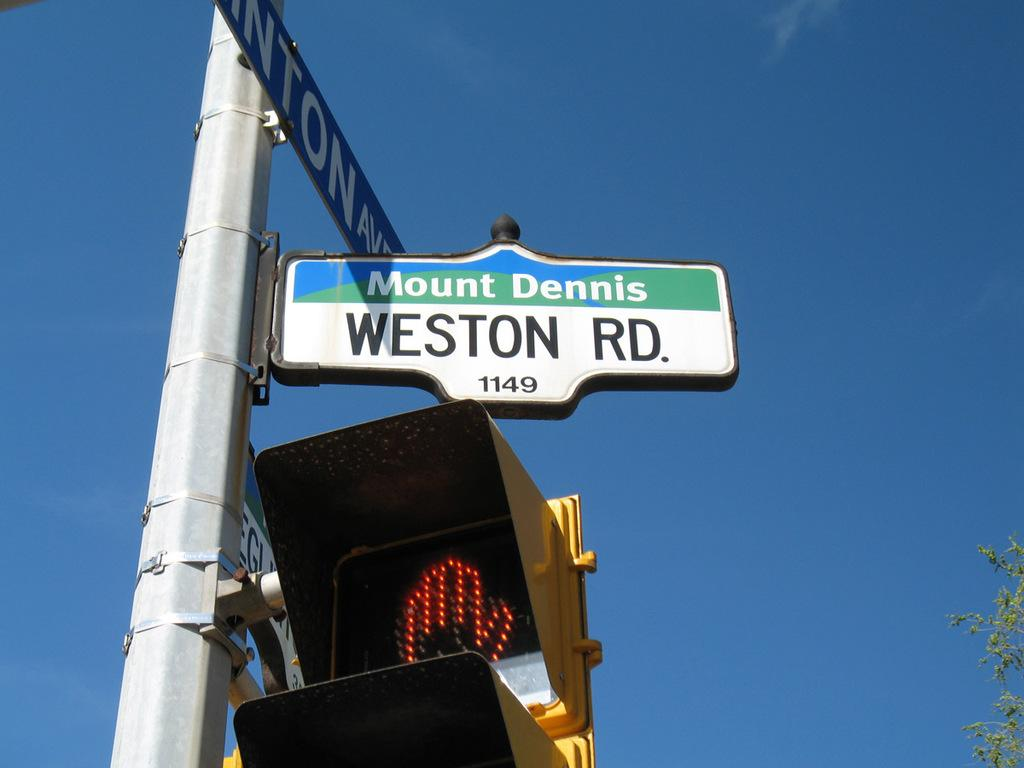<image>
Share a concise interpretation of the image provided. A sign at an intersection for Weston road. 